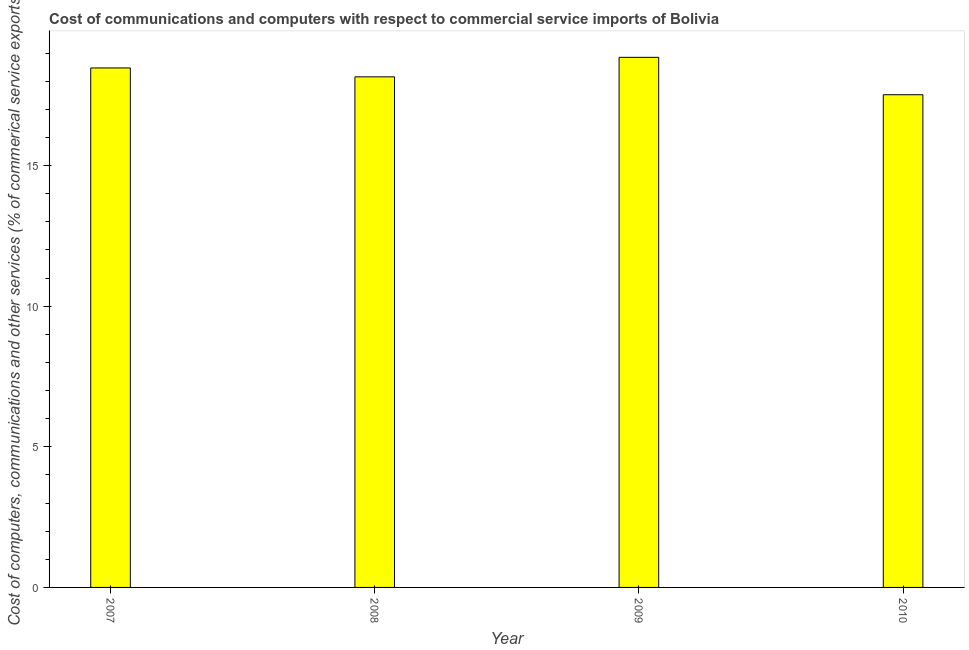What is the title of the graph?
Ensure brevity in your answer.  Cost of communications and computers with respect to commercial service imports of Bolivia. What is the label or title of the Y-axis?
Your answer should be compact. Cost of computers, communications and other services (% of commerical service exports). What is the cost of communications in 2008?
Offer a terse response. 18.15. Across all years, what is the maximum  computer and other services?
Your answer should be very brief. 18.85. Across all years, what is the minimum  computer and other services?
Provide a succinct answer. 17.52. In which year was the  computer and other services maximum?
Ensure brevity in your answer.  2009. What is the sum of the cost of communications?
Your answer should be very brief. 73. What is the difference between the  computer and other services in 2007 and 2009?
Offer a terse response. -0.38. What is the average cost of communications per year?
Your response must be concise. 18.25. What is the median  computer and other services?
Offer a terse response. 18.31. In how many years, is the cost of communications greater than 5 %?
Keep it short and to the point. 4. What is the ratio of the  computer and other services in 2009 to that in 2010?
Provide a short and direct response. 1.08. Is the difference between the cost of communications in 2008 and 2010 greater than the difference between any two years?
Provide a succinct answer. No. What is the difference between the highest and the second highest cost of communications?
Your answer should be very brief. 0.38. Is the sum of the  computer and other services in 2007 and 2010 greater than the maximum  computer and other services across all years?
Offer a terse response. Yes. What is the difference between the highest and the lowest  computer and other services?
Keep it short and to the point. 1.33. In how many years, is the  computer and other services greater than the average  computer and other services taken over all years?
Provide a short and direct response. 2. How many bars are there?
Give a very brief answer. 4. Are the values on the major ticks of Y-axis written in scientific E-notation?
Your response must be concise. No. What is the Cost of computers, communications and other services (% of commerical service exports) of 2007?
Keep it short and to the point. 18.47. What is the Cost of computers, communications and other services (% of commerical service exports) of 2008?
Ensure brevity in your answer.  18.15. What is the Cost of computers, communications and other services (% of commerical service exports) of 2009?
Your response must be concise. 18.85. What is the Cost of computers, communications and other services (% of commerical service exports) of 2010?
Offer a very short reply. 17.52. What is the difference between the Cost of computers, communications and other services (% of commerical service exports) in 2007 and 2008?
Provide a short and direct response. 0.32. What is the difference between the Cost of computers, communications and other services (% of commerical service exports) in 2007 and 2009?
Offer a terse response. -0.38. What is the difference between the Cost of computers, communications and other services (% of commerical service exports) in 2007 and 2010?
Your response must be concise. 0.95. What is the difference between the Cost of computers, communications and other services (% of commerical service exports) in 2008 and 2009?
Your answer should be very brief. -0.69. What is the difference between the Cost of computers, communications and other services (% of commerical service exports) in 2008 and 2010?
Provide a short and direct response. 0.64. What is the difference between the Cost of computers, communications and other services (% of commerical service exports) in 2009 and 2010?
Your response must be concise. 1.33. What is the ratio of the Cost of computers, communications and other services (% of commerical service exports) in 2007 to that in 2010?
Give a very brief answer. 1.05. What is the ratio of the Cost of computers, communications and other services (% of commerical service exports) in 2008 to that in 2010?
Ensure brevity in your answer.  1.04. What is the ratio of the Cost of computers, communications and other services (% of commerical service exports) in 2009 to that in 2010?
Your answer should be compact. 1.08. 